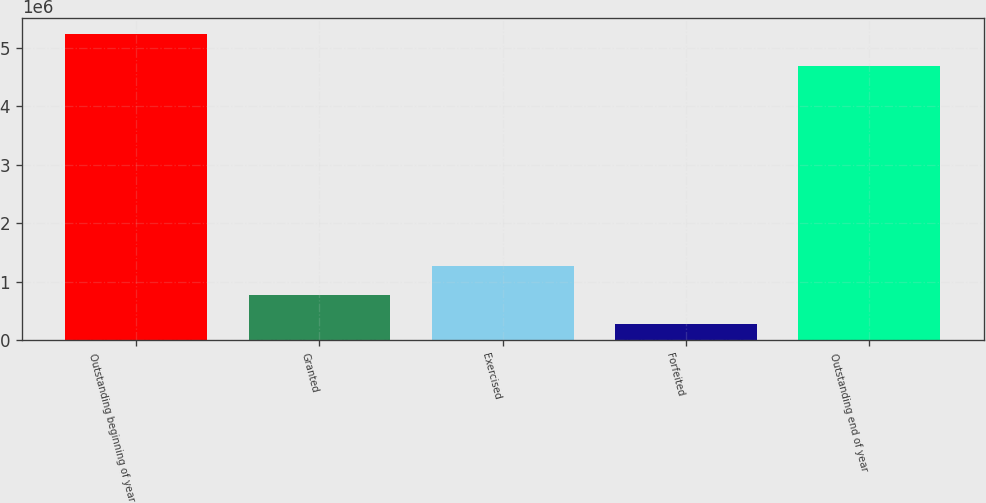<chart> <loc_0><loc_0><loc_500><loc_500><bar_chart><fcel>Outstanding beginning of year<fcel>Granted<fcel>Exercised<fcel>Forfeited<fcel>Outstanding end of year<nl><fcel>5.23546e+06<fcel>775440<fcel>1.271e+06<fcel>279882<fcel>4.69166e+06<nl></chart> 